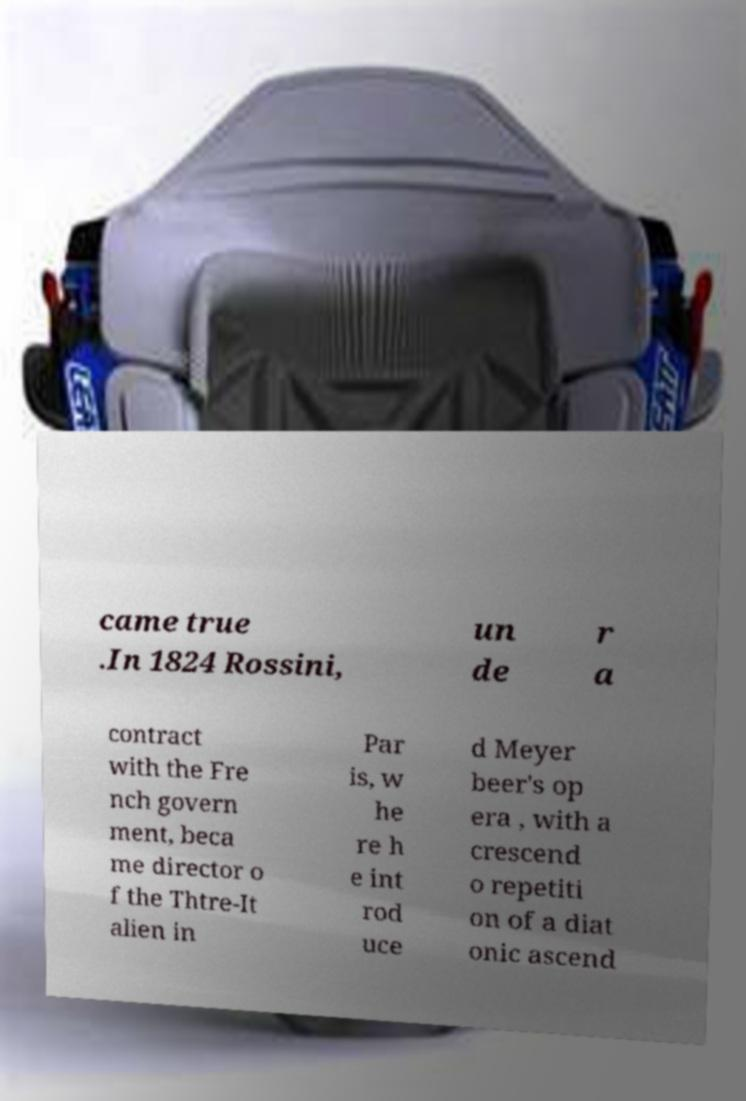Can you accurately transcribe the text from the provided image for me? came true .In 1824 Rossini, un de r a contract with the Fre nch govern ment, beca me director o f the Thtre-It alien in Par is, w he re h e int rod uce d Meyer beer's op era , with a crescend o repetiti on of a diat onic ascend 